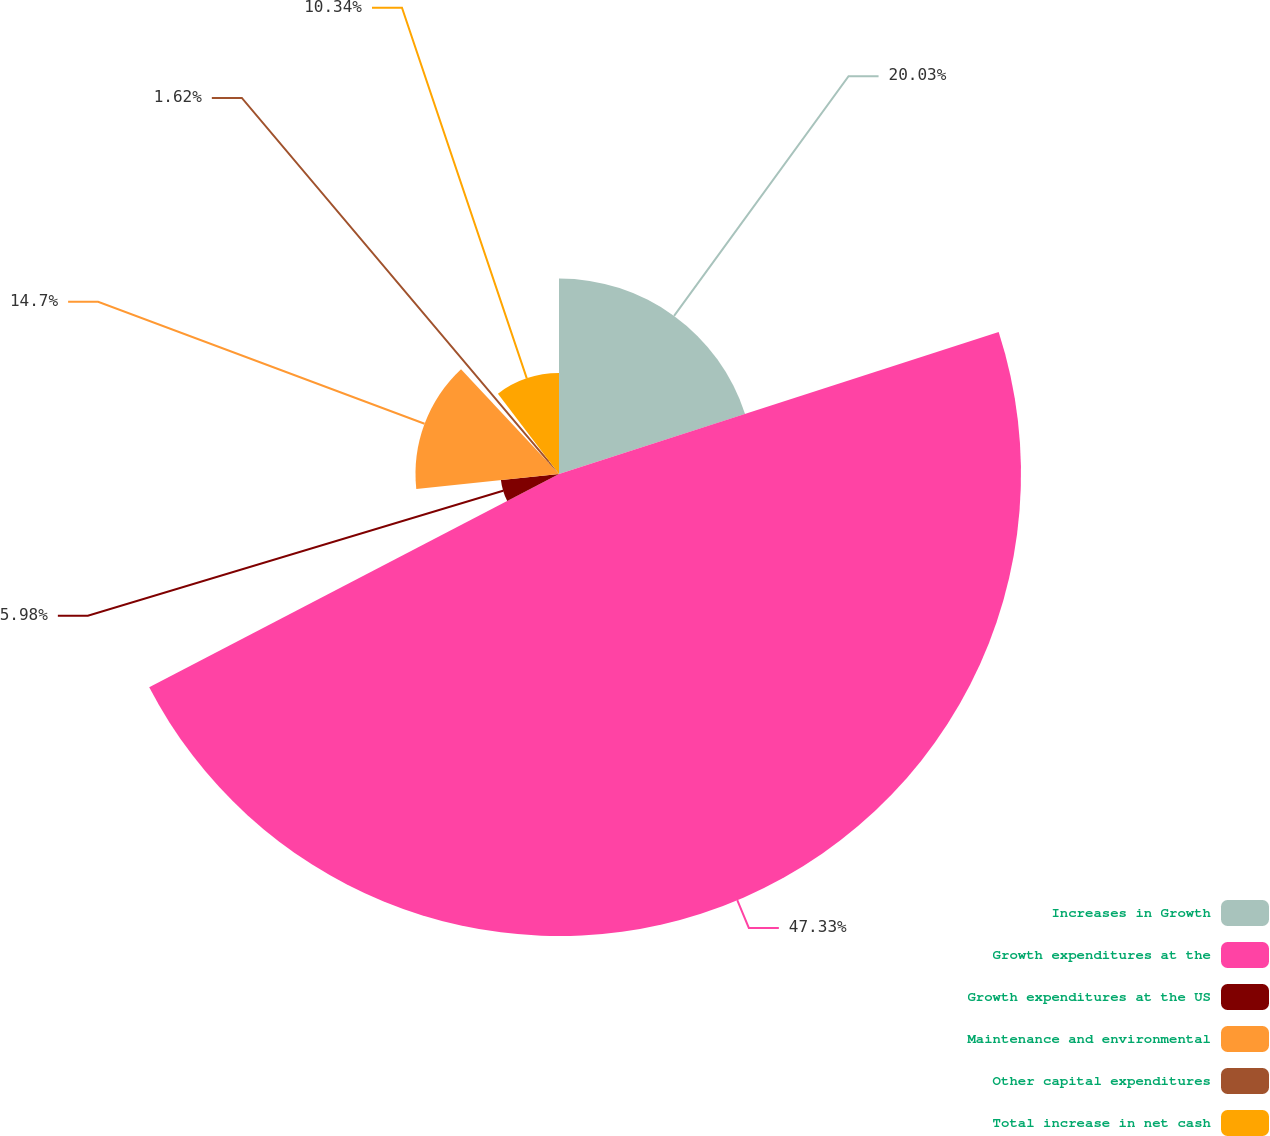Convert chart to OTSL. <chart><loc_0><loc_0><loc_500><loc_500><pie_chart><fcel>Increases in Growth<fcel>Growth expenditures at the<fcel>Growth expenditures at the US<fcel>Maintenance and environmental<fcel>Other capital expenditures<fcel>Total increase in net cash<nl><fcel>20.03%<fcel>47.33%<fcel>5.98%<fcel>14.7%<fcel>1.62%<fcel>10.34%<nl></chart> 